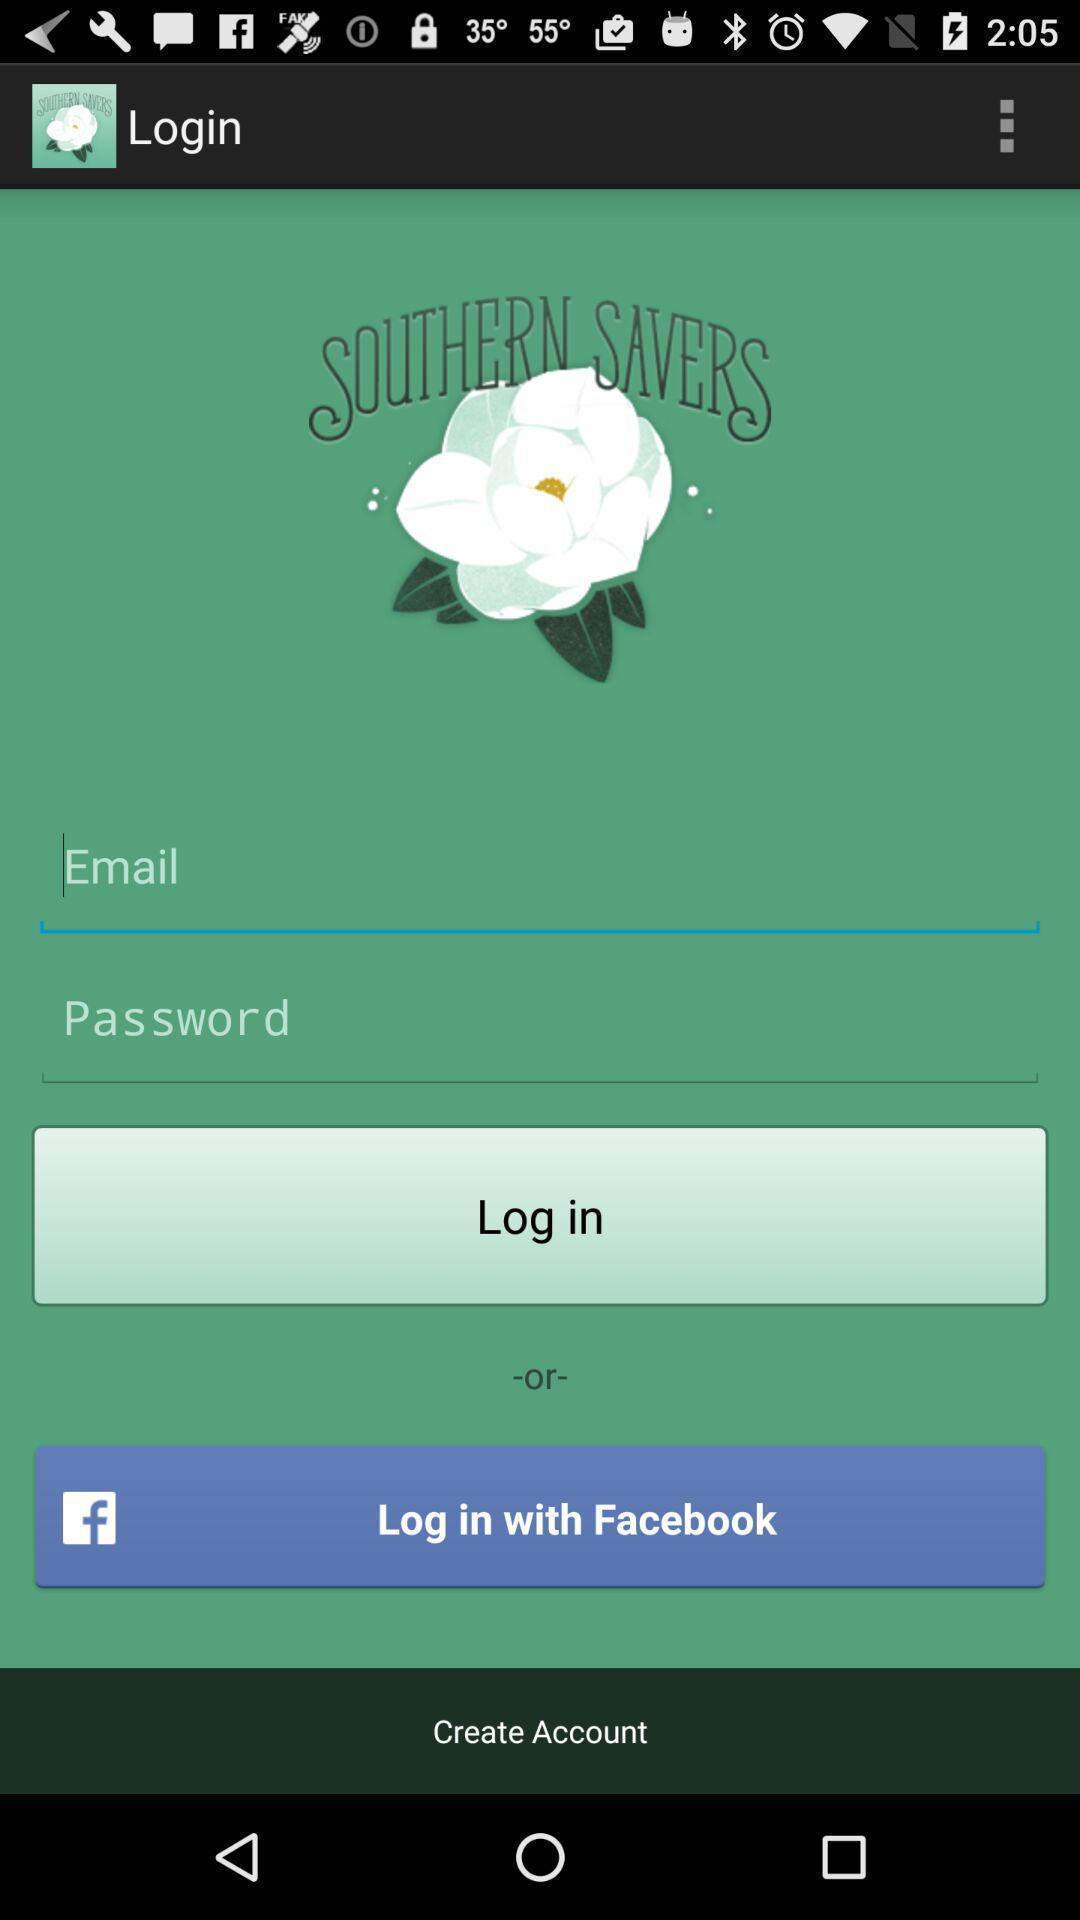Provide a textual representation of this image. Welcome page displaying different options to create or login account. 